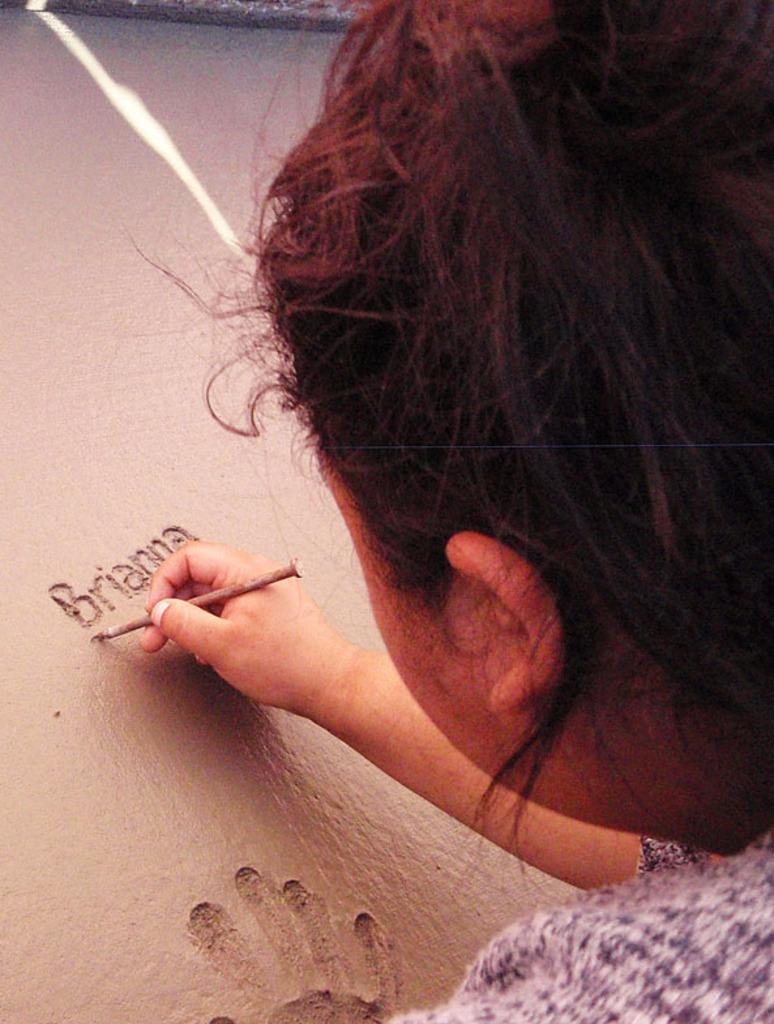Who is the main subject in the image? There is a girl in the image. What is the girl holding in her hand? The girl is holding something in her hand, but the specific object is not mentioned in the facts. Can you describe the brown-colored object with a word written on it? Yes, there is a brown-colored object with a word written on it in the image. What additional detail can be observed in the image? There is a handprint visible in the image. What type of thread is the girl using to control the horse in the image? There is no horse or thread present in the image. How does the girl's anger affect the objects in the image? The facts provided do not mention any emotions or actions related to anger, so it cannot be determined how the girl's anger might affect the objects in the image. 